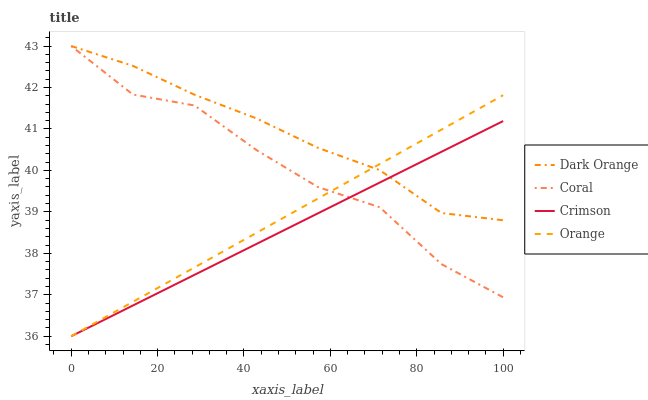Does Crimson have the minimum area under the curve?
Answer yes or no. Yes. Does Dark Orange have the maximum area under the curve?
Answer yes or no. Yes. Does Coral have the minimum area under the curve?
Answer yes or no. No. Does Coral have the maximum area under the curve?
Answer yes or no. No. Is Orange the smoothest?
Answer yes or no. Yes. Is Coral the roughest?
Answer yes or no. Yes. Is Dark Orange the smoothest?
Answer yes or no. No. Is Dark Orange the roughest?
Answer yes or no. No. Does Crimson have the lowest value?
Answer yes or no. Yes. Does Coral have the lowest value?
Answer yes or no. No. Does Coral have the highest value?
Answer yes or no. Yes. Does Orange have the highest value?
Answer yes or no. No. Does Coral intersect Crimson?
Answer yes or no. Yes. Is Coral less than Crimson?
Answer yes or no. No. Is Coral greater than Crimson?
Answer yes or no. No. 